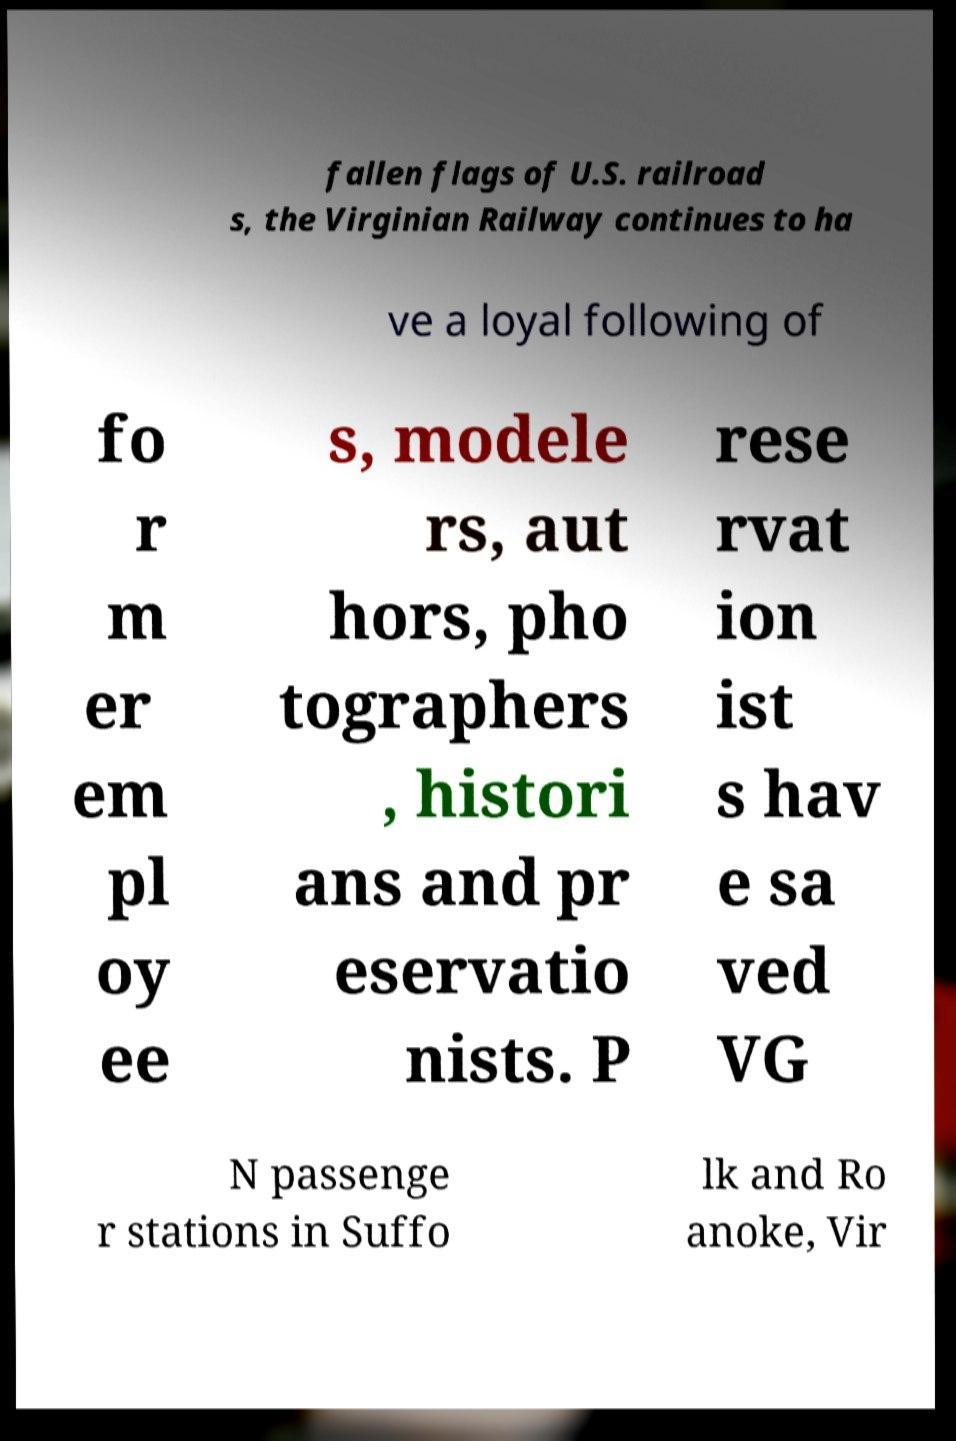Could you assist in decoding the text presented in this image and type it out clearly? fallen flags of U.S. railroad s, the Virginian Railway continues to ha ve a loyal following of fo r m er em pl oy ee s, modele rs, aut hors, pho tographers , histori ans and pr eservatio nists. P rese rvat ion ist s hav e sa ved VG N passenge r stations in Suffo lk and Ro anoke, Vir 